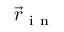Convert formula to latex. <formula><loc_0><loc_0><loc_500><loc_500>\vec { r } _ { i n }</formula> 